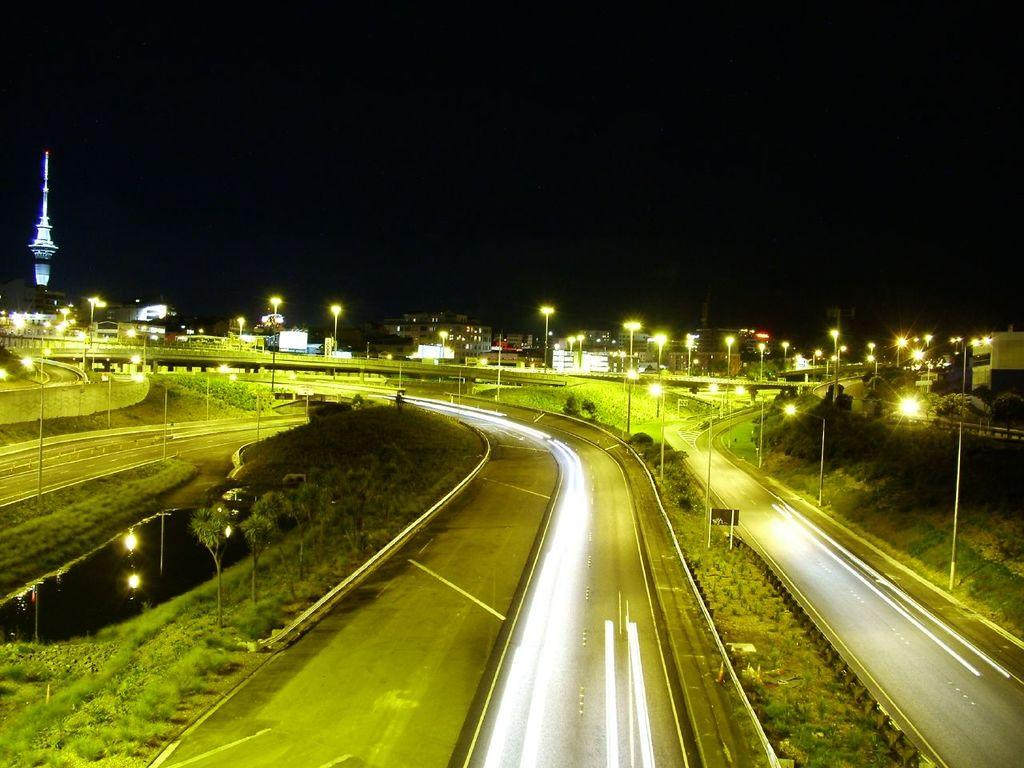What type of pathway can be seen in the image? There is a road in the image. What type of vegetation is present in the image? Trees are present in the image. What type of terrain is visible at the bottom of the image? There is grassy land at the bottom of the image. What type of structure is present in the image? There is a bridge in the image. What type of illumination is visible in the image? Lights are visible in the image. What type of man-made structures are present in the image? Buildings are present in the image. What is the condition of the sky in the image? The top of the image appears to be dark. Can you tell me how many bones are visible in the image? There are no bones present in the image. What type of stream is flowing under the bridge in the image? There is no stream visible in the image; only a road, trees, grassy land, a bridge, lights, buildings, and a dark sky are present. 